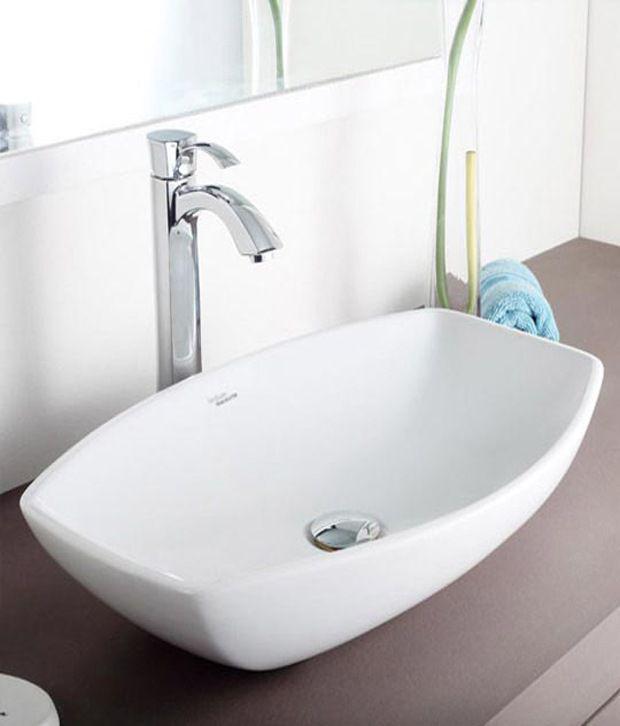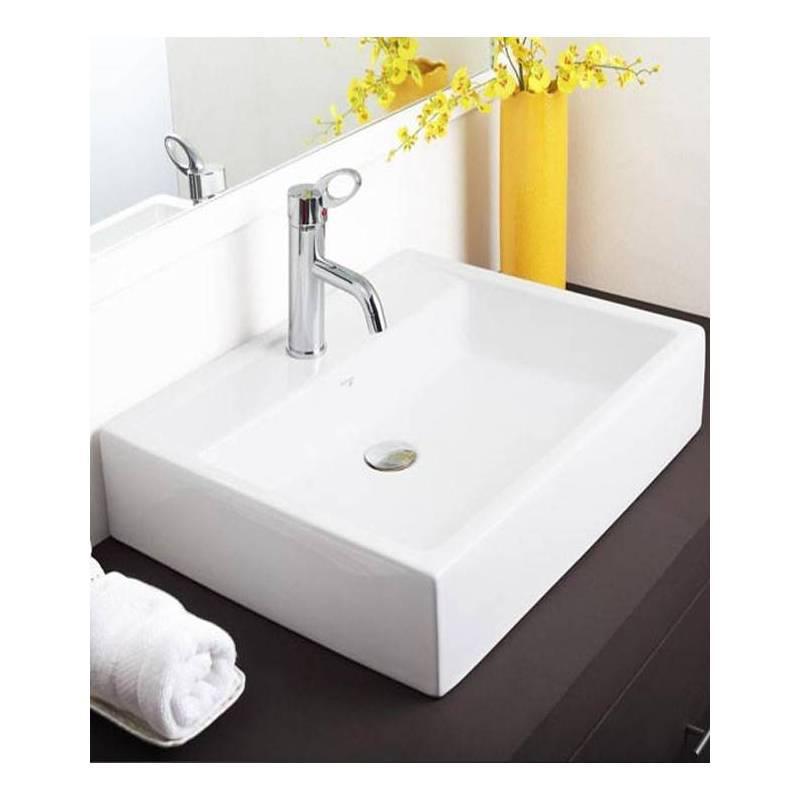The first image is the image on the left, the second image is the image on the right. Analyze the images presented: Is the assertion "In one of the images there is a vase with yellow flowers placed on a counter next to a sink." valid? Answer yes or no. Yes. 